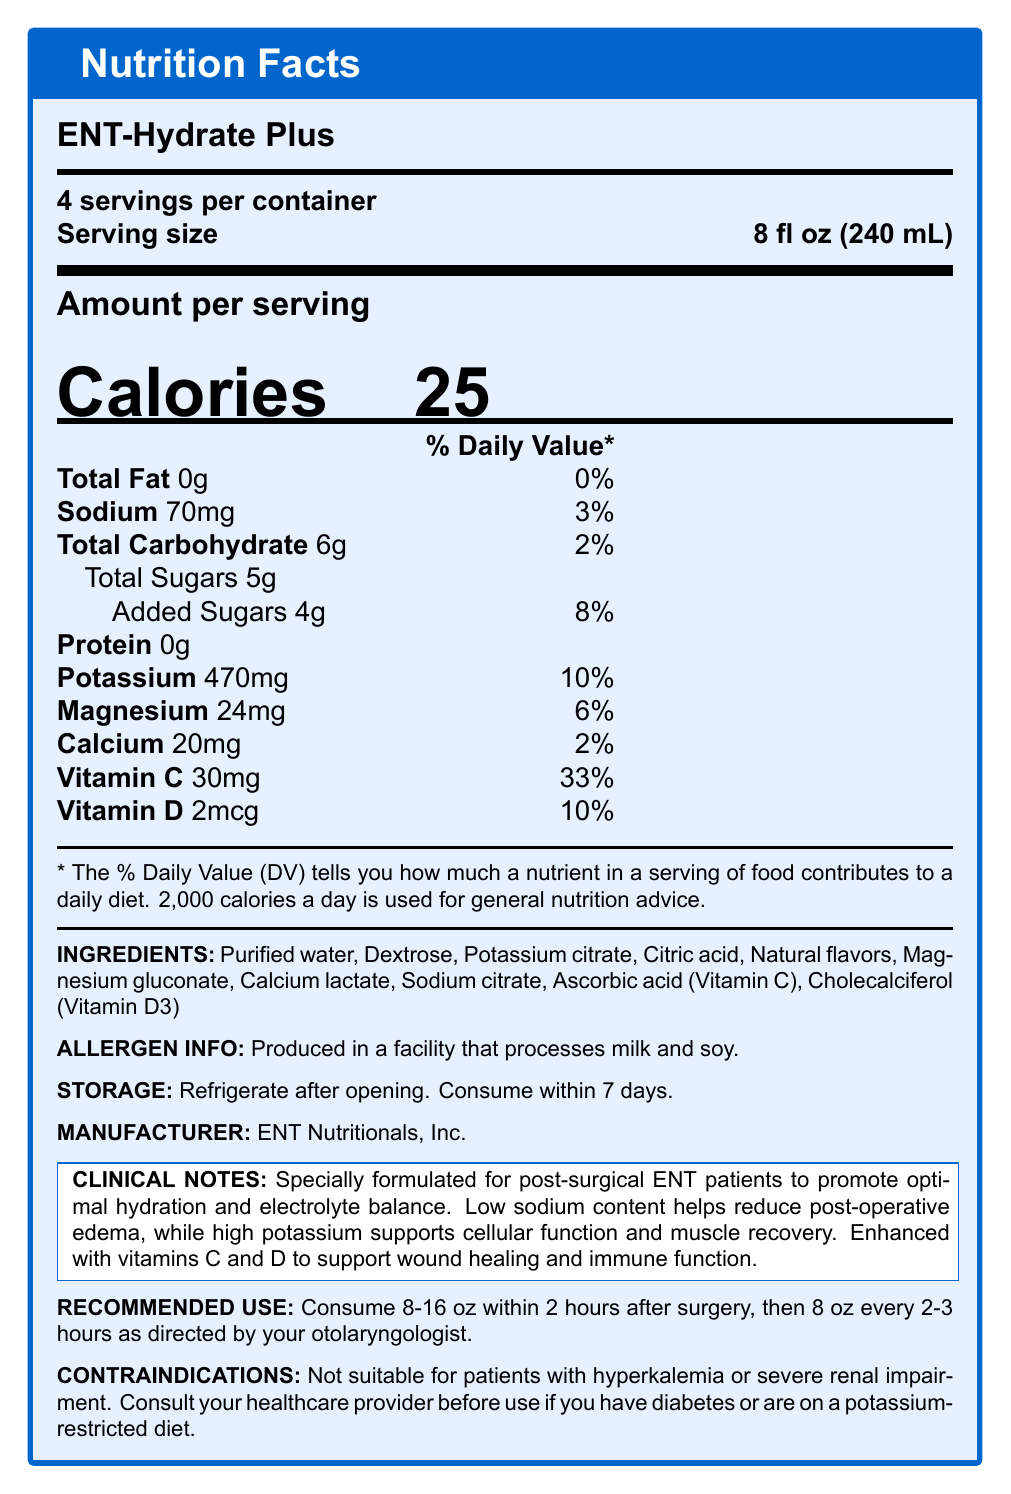What are the main electrolytes listed in the nutrition facts? The electrolytes mentioned in the Nutrition Facts Label for ENT-Hydrate Plus are potassium, sodium, magnesium, and calcium.
Answer: Potassium, Sodium, Magnesium, Calcium How many calories are present per serving of ENT-Hydrate Plus? The Nutrition Facts Label states that there are 25 calories per serving.
Answer: 25 What is the serving size for ENT-Hydrate Plus? The serving size listed in the Nutrition Facts Label is 8 fl oz (240 mL).
Answer: 8 fl oz (240 mL) What is the amount of sodium per serving in ENT-Hydrate Plus? According to the document, the sodium content per serving is 70 mg.
Answer: 70 mg Is ENT-Hydrate Plus suitable for patients with severe renal impairment? The contraindications section specifies that this drink is not suitable for patients with severe renal impairment.
Answer: No Which nutrient has the highest daily value percentage per serving? A. Vitamin C B. Potassium C. Calcium D. Vitamin D The Nutrition Facts Label shows that Vitamin C has a daily value of 33%, which is higher than all other listed nutrients.
Answer: A. Vitamin C How much potassium is in one serving of ENT-Hydrate Plus? The Nutrition Facts Label states that there are 470 mg of potassium per serving, contributing to 10% of the daily value.
Answer: 470 mg What should you do with ENT-Hydrate Plus after opening it? The storage instructions specify to refrigerate the drink after opening and consume it within 7 days.
Answer: Refrigerate after opening. Consume within 7 days. What additional vitamins are provided in ENT-Hydrate Plus? The Nutrition Facts Label lists Vitamin C and Vitamin D as added vitamins.
Answer: Vitamin C and Vitamin D What is the allergen information provided on the label? The allergen information mentions that the product is produced in a facility that processes milk and soy.
Answer: Produced in a facility that processes milk and soy. What company manufactures ENT-Hydrate Plus? The manufacturer listed is ENT Nutritionals, Inc.
Answer: ENT Nutritionals, Inc. What is the primary purpose of ENT-Hydrate Plus according to the clinical notes? The clinical notes specify that the drink is formulated to promote hydration and electrolyte balance post-surgery, with additional benefits like reduced edema and support for muscle recovery.
Answer: To promote optimal hydration and electrolyte balance for post-surgical ENT patients. Based on the label, what is the recommended use for ENT-Hydrate Plus post-surgery? The recommended use suggests drinking 8-16 oz within 2 hours post-surgery, followed by 8 oz every 2-3 hours as directed by a healthcare provider.
Answer: Consume 8-16 oz within 2 hours after surgery, then 8 oz every 2-3 hours as directed by your otolaryngologist. True/False: ENT-Hydrate Plus contains 6 gm of protein per serving. The Nutrition Facts Label clearly states that the protein content per serving is 0 gm.
Answer: False Describe the main functionalities and nutritional benefits of the ENT-Hydrate Plus. The drink is specifically formulated to meet the hydration and nutrition needs of post-surgical ENT patients, providing essential electrolytes and vitamins to support healing and recovery.
Answer: ENT-Hydrate Plus is a low-sodium, high-potassium electrolyte drink designed for post-surgical hydration in ENT patients. It promotes optimal hydration, reduces post-operative edema, supports cellular function and muscle recovery, and enhances wound healing and immune function with added vitamins C and D. What is the source of potassium in ENT-Hydrate Plus? The Nutrition Facts Label does not specify the exact source of potassium; it only lists the amount present.
Answer: Cannot be determined What is the percentage of daily value of added sugars in ENT-Hydrate Plus? The Nutrition Facts Label indicates that added sugars constitute 8% of the daily value.
Answer: 8% 